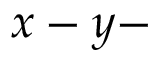<formula> <loc_0><loc_0><loc_500><loc_500>x - y -</formula> 